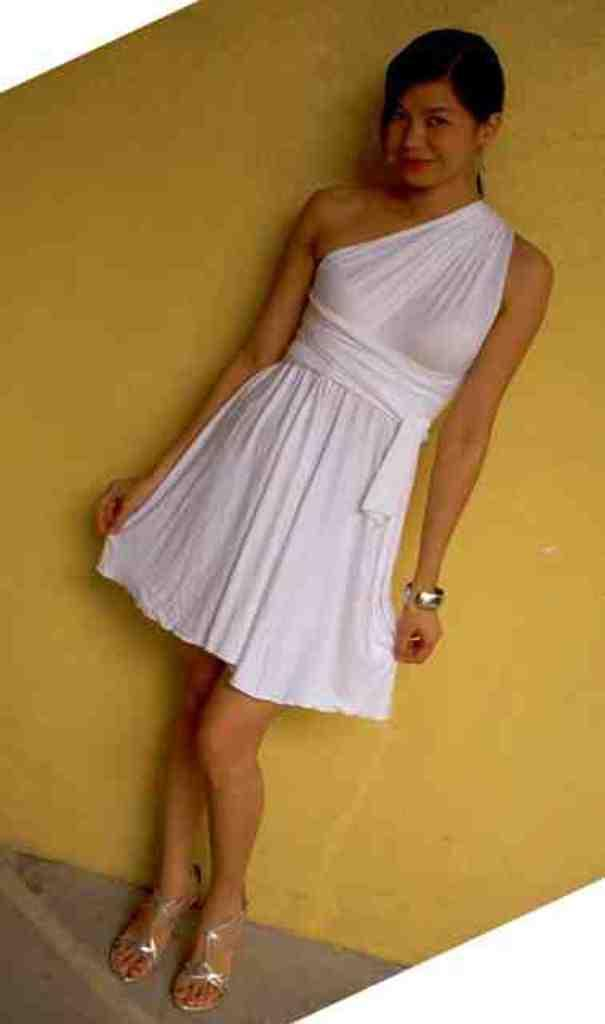Who is the main subject in the image? There is a woman in the image. What is the woman wearing? The woman is wearing a white dress. Where is the woman positioned in the image? The woman is standing on the floor and leaning against a wall. What is the woman's facial expression in the image? The woman is smiling. What is the woman doing in the image? The woman is giving a pose for the picture. What type of heat can be felt coming from the woman in the image? There is no indication of heat or temperature in the image, and therefore it cannot be determined from the image. 